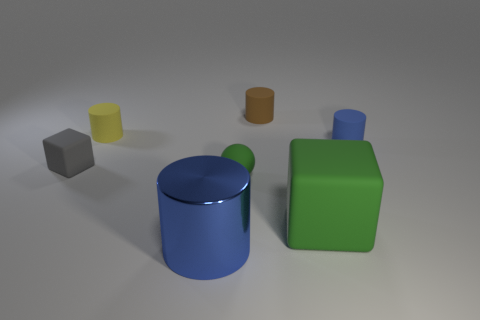Are the large blue cylinder and the blue cylinder behind the small green thing made of the same material? While both cylinders share a similar hue of blue, it's not possible to conclusively determine if they're made of the same material solely from this image. The visible textures and any potential reflections would provide better clues, however, based on this image alone, we can't ascertain the material composition with certainty. 